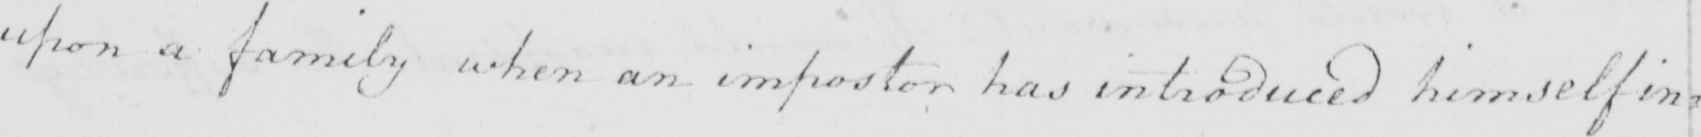Transcribe the text shown in this historical manuscript line. upon a family when an impostor has introduced himself in= 